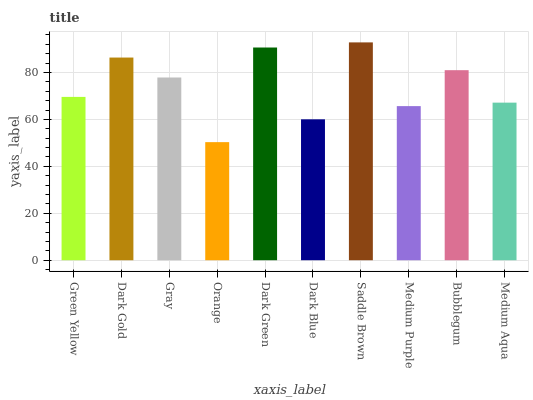Is Orange the minimum?
Answer yes or no. Yes. Is Saddle Brown the maximum?
Answer yes or no. Yes. Is Dark Gold the minimum?
Answer yes or no. No. Is Dark Gold the maximum?
Answer yes or no. No. Is Dark Gold greater than Green Yellow?
Answer yes or no. Yes. Is Green Yellow less than Dark Gold?
Answer yes or no. Yes. Is Green Yellow greater than Dark Gold?
Answer yes or no. No. Is Dark Gold less than Green Yellow?
Answer yes or no. No. Is Gray the high median?
Answer yes or no. Yes. Is Green Yellow the low median?
Answer yes or no. Yes. Is Saddle Brown the high median?
Answer yes or no. No. Is Medium Purple the low median?
Answer yes or no. No. 